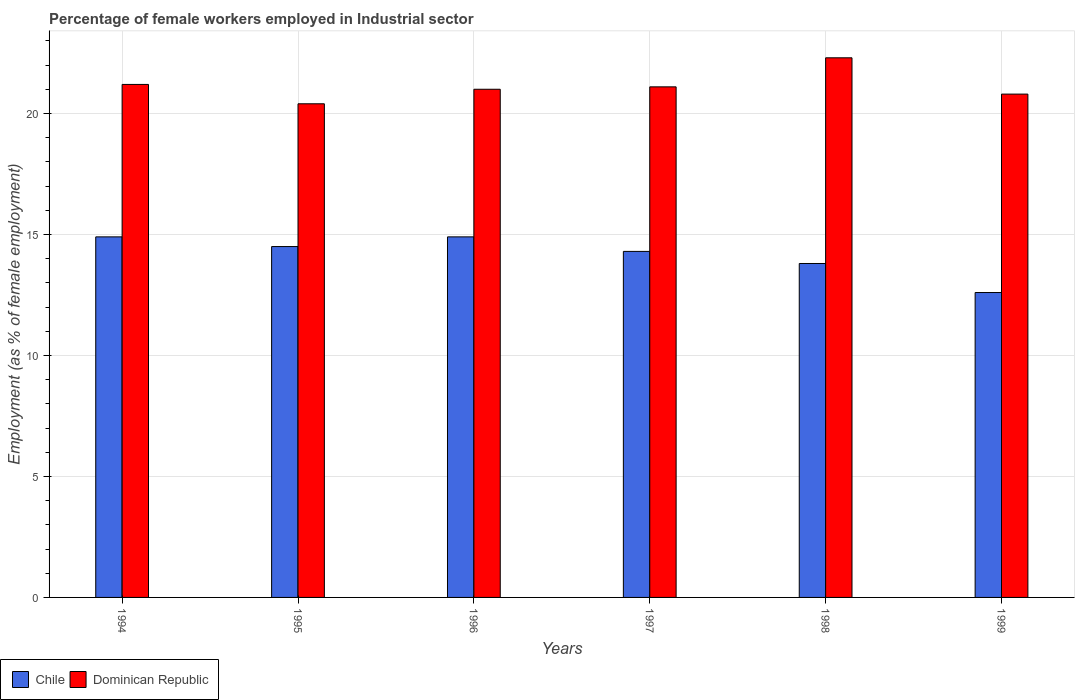Are the number of bars per tick equal to the number of legend labels?
Your answer should be very brief. Yes. Are the number of bars on each tick of the X-axis equal?
Make the answer very short. Yes. What is the label of the 6th group of bars from the left?
Offer a very short reply. 1999. In how many cases, is the number of bars for a given year not equal to the number of legend labels?
Ensure brevity in your answer.  0. What is the percentage of females employed in Industrial sector in Dominican Republic in 1997?
Your response must be concise. 21.1. Across all years, what is the maximum percentage of females employed in Industrial sector in Chile?
Give a very brief answer. 14.9. Across all years, what is the minimum percentage of females employed in Industrial sector in Chile?
Ensure brevity in your answer.  12.6. In which year was the percentage of females employed in Industrial sector in Dominican Republic maximum?
Ensure brevity in your answer.  1998. What is the total percentage of females employed in Industrial sector in Dominican Republic in the graph?
Your answer should be compact. 126.8. What is the difference between the percentage of females employed in Industrial sector in Dominican Republic in 1994 and that in 1999?
Offer a terse response. 0.4. What is the difference between the percentage of females employed in Industrial sector in Chile in 1997 and the percentage of females employed in Industrial sector in Dominican Republic in 1994?
Provide a succinct answer. -6.9. What is the average percentage of females employed in Industrial sector in Chile per year?
Give a very brief answer. 14.17. In the year 1997, what is the difference between the percentage of females employed in Industrial sector in Chile and percentage of females employed in Industrial sector in Dominican Republic?
Your answer should be very brief. -6.8. In how many years, is the percentage of females employed in Industrial sector in Chile greater than 19 %?
Make the answer very short. 0. What is the ratio of the percentage of females employed in Industrial sector in Chile in 1997 to that in 1999?
Your response must be concise. 1.13. Is the difference between the percentage of females employed in Industrial sector in Chile in 1995 and 1997 greater than the difference between the percentage of females employed in Industrial sector in Dominican Republic in 1995 and 1997?
Keep it short and to the point. Yes. What is the difference between the highest and the second highest percentage of females employed in Industrial sector in Dominican Republic?
Provide a short and direct response. 1.1. What is the difference between the highest and the lowest percentage of females employed in Industrial sector in Dominican Republic?
Ensure brevity in your answer.  1.9. In how many years, is the percentage of females employed in Industrial sector in Chile greater than the average percentage of females employed in Industrial sector in Chile taken over all years?
Offer a very short reply. 4. Is the sum of the percentage of females employed in Industrial sector in Chile in 1996 and 1998 greater than the maximum percentage of females employed in Industrial sector in Dominican Republic across all years?
Your answer should be compact. Yes. Are all the bars in the graph horizontal?
Your answer should be very brief. No. Where does the legend appear in the graph?
Provide a short and direct response. Bottom left. How many legend labels are there?
Your response must be concise. 2. What is the title of the graph?
Your answer should be compact. Percentage of female workers employed in Industrial sector. What is the label or title of the Y-axis?
Provide a short and direct response. Employment (as % of female employment). What is the Employment (as % of female employment) of Chile in 1994?
Your response must be concise. 14.9. What is the Employment (as % of female employment) of Dominican Republic in 1994?
Give a very brief answer. 21.2. What is the Employment (as % of female employment) in Dominican Republic in 1995?
Offer a terse response. 20.4. What is the Employment (as % of female employment) in Chile in 1996?
Ensure brevity in your answer.  14.9. What is the Employment (as % of female employment) of Chile in 1997?
Your response must be concise. 14.3. What is the Employment (as % of female employment) of Dominican Republic in 1997?
Your answer should be very brief. 21.1. What is the Employment (as % of female employment) of Chile in 1998?
Provide a succinct answer. 13.8. What is the Employment (as % of female employment) of Dominican Republic in 1998?
Make the answer very short. 22.3. What is the Employment (as % of female employment) in Chile in 1999?
Provide a succinct answer. 12.6. What is the Employment (as % of female employment) in Dominican Republic in 1999?
Your answer should be compact. 20.8. Across all years, what is the maximum Employment (as % of female employment) of Chile?
Your answer should be very brief. 14.9. Across all years, what is the maximum Employment (as % of female employment) of Dominican Republic?
Offer a very short reply. 22.3. Across all years, what is the minimum Employment (as % of female employment) in Chile?
Provide a succinct answer. 12.6. Across all years, what is the minimum Employment (as % of female employment) in Dominican Republic?
Give a very brief answer. 20.4. What is the total Employment (as % of female employment) in Dominican Republic in the graph?
Your response must be concise. 126.8. What is the difference between the Employment (as % of female employment) of Chile in 1994 and that in 1996?
Provide a succinct answer. 0. What is the difference between the Employment (as % of female employment) of Dominican Republic in 1994 and that in 1996?
Offer a very short reply. 0.2. What is the difference between the Employment (as % of female employment) in Chile in 1994 and that in 1998?
Offer a terse response. 1.1. What is the difference between the Employment (as % of female employment) in Dominican Republic in 1994 and that in 1998?
Keep it short and to the point. -1.1. What is the difference between the Employment (as % of female employment) in Dominican Republic in 1994 and that in 1999?
Ensure brevity in your answer.  0.4. What is the difference between the Employment (as % of female employment) in Chile in 1995 and that in 1996?
Make the answer very short. -0.4. What is the difference between the Employment (as % of female employment) of Dominican Republic in 1995 and that in 1996?
Provide a short and direct response. -0.6. What is the difference between the Employment (as % of female employment) in Dominican Republic in 1995 and that in 1997?
Make the answer very short. -0.7. What is the difference between the Employment (as % of female employment) in Chile in 1996 and that in 1998?
Your answer should be compact. 1.1. What is the difference between the Employment (as % of female employment) in Chile in 1996 and that in 1999?
Ensure brevity in your answer.  2.3. What is the difference between the Employment (as % of female employment) in Dominican Republic in 1996 and that in 1999?
Give a very brief answer. 0.2. What is the difference between the Employment (as % of female employment) in Chile in 1997 and that in 1999?
Ensure brevity in your answer.  1.7. What is the difference between the Employment (as % of female employment) in Dominican Republic in 1997 and that in 1999?
Offer a very short reply. 0.3. What is the difference between the Employment (as % of female employment) of Chile in 1994 and the Employment (as % of female employment) of Dominican Republic in 1996?
Keep it short and to the point. -6.1. What is the difference between the Employment (as % of female employment) in Chile in 1994 and the Employment (as % of female employment) in Dominican Republic in 1998?
Offer a very short reply. -7.4. What is the difference between the Employment (as % of female employment) of Chile in 1995 and the Employment (as % of female employment) of Dominican Republic in 1996?
Give a very brief answer. -6.5. What is the difference between the Employment (as % of female employment) of Chile in 1995 and the Employment (as % of female employment) of Dominican Republic in 1998?
Your answer should be very brief. -7.8. What is the difference between the Employment (as % of female employment) of Chile in 1996 and the Employment (as % of female employment) of Dominican Republic in 1999?
Offer a terse response. -5.9. What is the difference between the Employment (as % of female employment) of Chile in 1997 and the Employment (as % of female employment) of Dominican Republic in 1998?
Offer a very short reply. -8. What is the difference between the Employment (as % of female employment) in Chile in 1998 and the Employment (as % of female employment) in Dominican Republic in 1999?
Provide a short and direct response. -7. What is the average Employment (as % of female employment) of Chile per year?
Your response must be concise. 14.17. What is the average Employment (as % of female employment) of Dominican Republic per year?
Provide a succinct answer. 21.13. In the year 1994, what is the difference between the Employment (as % of female employment) in Chile and Employment (as % of female employment) in Dominican Republic?
Offer a very short reply. -6.3. In the year 1995, what is the difference between the Employment (as % of female employment) of Chile and Employment (as % of female employment) of Dominican Republic?
Your answer should be very brief. -5.9. In the year 1996, what is the difference between the Employment (as % of female employment) in Chile and Employment (as % of female employment) in Dominican Republic?
Your answer should be compact. -6.1. In the year 1997, what is the difference between the Employment (as % of female employment) of Chile and Employment (as % of female employment) of Dominican Republic?
Ensure brevity in your answer.  -6.8. In the year 1999, what is the difference between the Employment (as % of female employment) in Chile and Employment (as % of female employment) in Dominican Republic?
Provide a short and direct response. -8.2. What is the ratio of the Employment (as % of female employment) of Chile in 1994 to that in 1995?
Keep it short and to the point. 1.03. What is the ratio of the Employment (as % of female employment) in Dominican Republic in 1994 to that in 1995?
Give a very brief answer. 1.04. What is the ratio of the Employment (as % of female employment) in Chile in 1994 to that in 1996?
Give a very brief answer. 1. What is the ratio of the Employment (as % of female employment) of Dominican Republic in 1994 to that in 1996?
Make the answer very short. 1.01. What is the ratio of the Employment (as % of female employment) in Chile in 1994 to that in 1997?
Offer a very short reply. 1.04. What is the ratio of the Employment (as % of female employment) in Chile in 1994 to that in 1998?
Provide a succinct answer. 1.08. What is the ratio of the Employment (as % of female employment) in Dominican Republic in 1994 to that in 1998?
Your answer should be very brief. 0.95. What is the ratio of the Employment (as % of female employment) of Chile in 1994 to that in 1999?
Give a very brief answer. 1.18. What is the ratio of the Employment (as % of female employment) in Dominican Republic in 1994 to that in 1999?
Your answer should be very brief. 1.02. What is the ratio of the Employment (as % of female employment) in Chile in 1995 to that in 1996?
Provide a short and direct response. 0.97. What is the ratio of the Employment (as % of female employment) in Dominican Republic in 1995 to that in 1996?
Make the answer very short. 0.97. What is the ratio of the Employment (as % of female employment) in Dominican Republic in 1995 to that in 1997?
Give a very brief answer. 0.97. What is the ratio of the Employment (as % of female employment) in Chile in 1995 to that in 1998?
Give a very brief answer. 1.05. What is the ratio of the Employment (as % of female employment) of Dominican Republic in 1995 to that in 1998?
Keep it short and to the point. 0.91. What is the ratio of the Employment (as % of female employment) in Chile in 1995 to that in 1999?
Provide a succinct answer. 1.15. What is the ratio of the Employment (as % of female employment) in Dominican Republic in 1995 to that in 1999?
Ensure brevity in your answer.  0.98. What is the ratio of the Employment (as % of female employment) in Chile in 1996 to that in 1997?
Provide a succinct answer. 1.04. What is the ratio of the Employment (as % of female employment) of Chile in 1996 to that in 1998?
Give a very brief answer. 1.08. What is the ratio of the Employment (as % of female employment) of Dominican Republic in 1996 to that in 1998?
Your response must be concise. 0.94. What is the ratio of the Employment (as % of female employment) of Chile in 1996 to that in 1999?
Ensure brevity in your answer.  1.18. What is the ratio of the Employment (as % of female employment) of Dominican Republic in 1996 to that in 1999?
Your response must be concise. 1.01. What is the ratio of the Employment (as % of female employment) of Chile in 1997 to that in 1998?
Offer a very short reply. 1.04. What is the ratio of the Employment (as % of female employment) of Dominican Republic in 1997 to that in 1998?
Your answer should be compact. 0.95. What is the ratio of the Employment (as % of female employment) of Chile in 1997 to that in 1999?
Ensure brevity in your answer.  1.13. What is the ratio of the Employment (as % of female employment) of Dominican Republic in 1997 to that in 1999?
Provide a succinct answer. 1.01. What is the ratio of the Employment (as % of female employment) in Chile in 1998 to that in 1999?
Ensure brevity in your answer.  1.1. What is the ratio of the Employment (as % of female employment) in Dominican Republic in 1998 to that in 1999?
Your response must be concise. 1.07. What is the difference between the highest and the second highest Employment (as % of female employment) of Chile?
Keep it short and to the point. 0. What is the difference between the highest and the second highest Employment (as % of female employment) in Dominican Republic?
Your answer should be compact. 1.1. 